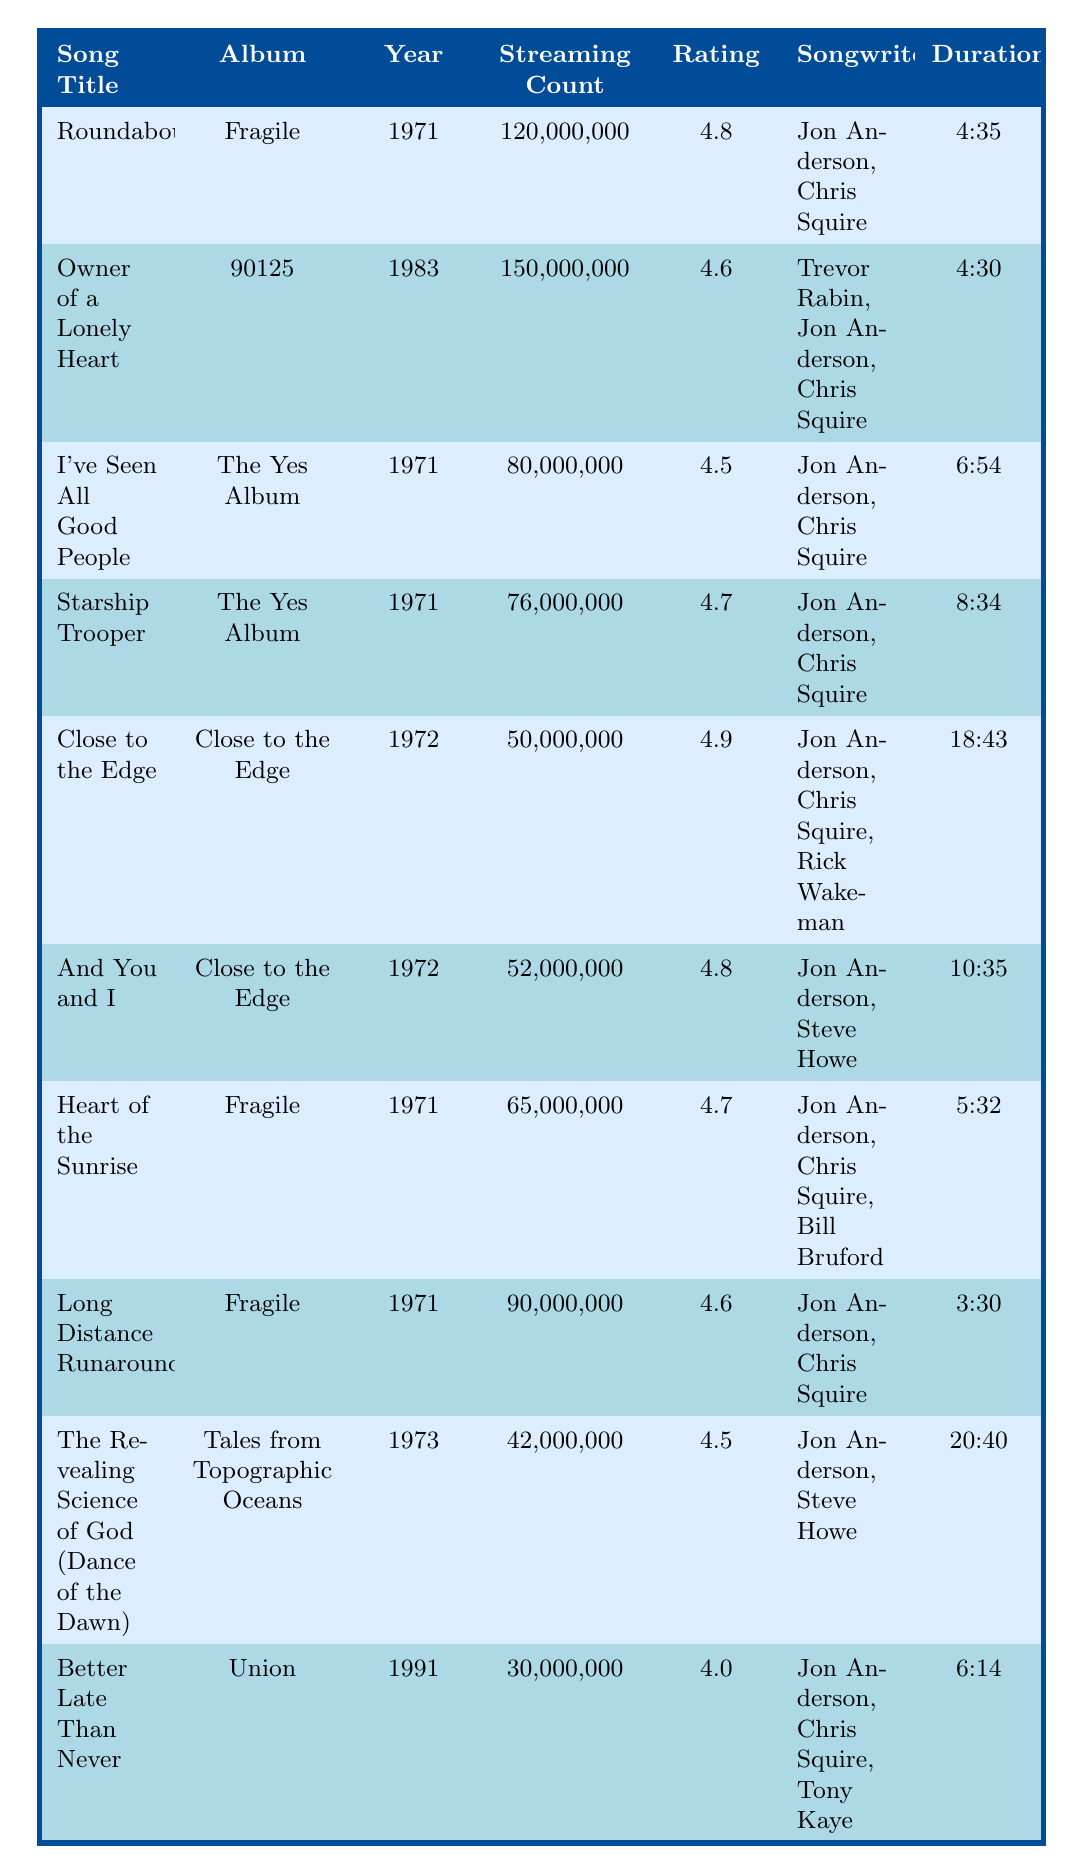What is the song with the highest streaming count? By looking at the "Streaming Count" column in the table, "Owner of a Lonely Heart" has the highest count at 150,000,000 streams.
Answer: Owner of a Lonely Heart Which song has the lowest average rating? In the "Rating" column, "Better Late Than Never" has the lowest rating at 4.0.
Answer: Better Late Than Never What is the total streaming count of all songs listed? The total streaming count is calculated by summing all the values in the "Streaming Count" column: 120,000,000 + 150,000,000 + 80,000,000 + 76,000,000 + 50,000,000 + 52,000,000 + 65,000,000 + 90,000,000 + 42,000,000 + 30,000,000 = 735,000,000.
Answer: 735,000,000 How many songs were released in the 1970s? By checking the "Year" column, "Roundabout," "I've Seen All Good People," "Starship Trooper," "Close to the Edge," "And You and I," "Heart of the Sunrise," and "Long Distance Runaround" were released in the 1970s, totaling 7 songs.
Answer: 7 What is the average duration of the songs listed? To calculate the average duration, first convert each time into seconds: (275 + 270 + 414 + 514 + 1123 + 635 + 332 + 210 + 1240 + 374) = 2877 seconds. Then divide by the number of songs (10): 2877 / 10 = 287.7 seconds, which is about 4 minutes and 47.7 seconds.
Answer: Approximately 4:48 Has any song in the list been rated higher than 4.8? Looking at the "Rating" column, "Roundabout" and "Close to the Edge" both have ratings higher than 4.8 (4.8 and 4.9 respectively).
Answer: Yes What is the difference in streaming counts between the most and least streamed songs? The most streamed song is "Owner of a Lonely Heart" with 150,000,000 streams and the least streamed is "Better Late Than Never" with 30,000,000 streams, so the difference is 150,000,000 - 30,000,000 = 120,000,000.
Answer: 120,000,000 Which songwriters collaborated on "Heart of the Sunrise"? In the "Songwriters" column for "Heart of the Sunrise," it lists Jon Anderson, Chris Squire, and Bill Bruford as the songwriters.
Answer: Jon Anderson, Chris Squire, Bill Bruford What is the total number of songwriters for the song "Owner of a Lonely Heart"? The "Songwriters" column for "Owner of a Lonely Heart" shows Trevor Rabin, Jon Anderson, and Chris Squire, totaling 3 songwriters.
Answer: 3 Which album has the most songs listed? The "Album" column shows that "Fragile" and "The Yes Album" each have 3 songs listed ("Roundabout," "Heart of the Sunrise," "Long Distance Runaround" from "Fragile" and "I've Seen All Good People," "Starship Trooper" from "The Yes Album").
Answer: Fragile and The Yes Album 